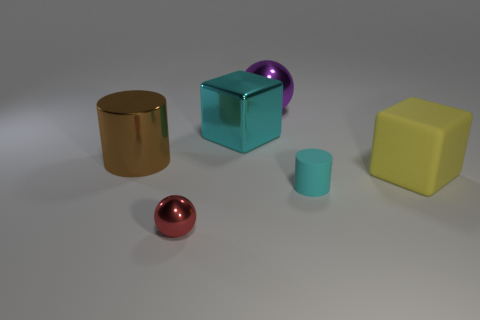Subtract all yellow cubes. Subtract all purple balls. How many cubes are left? 1 Add 1 purple metal things. How many objects exist? 7 Subtract all cubes. How many objects are left? 4 Add 1 tiny cyan matte objects. How many tiny cyan matte objects exist? 2 Subtract 0 green cubes. How many objects are left? 6 Subtract all red objects. Subtract all big cyan metallic blocks. How many objects are left? 4 Add 4 yellow rubber cubes. How many yellow rubber cubes are left? 5 